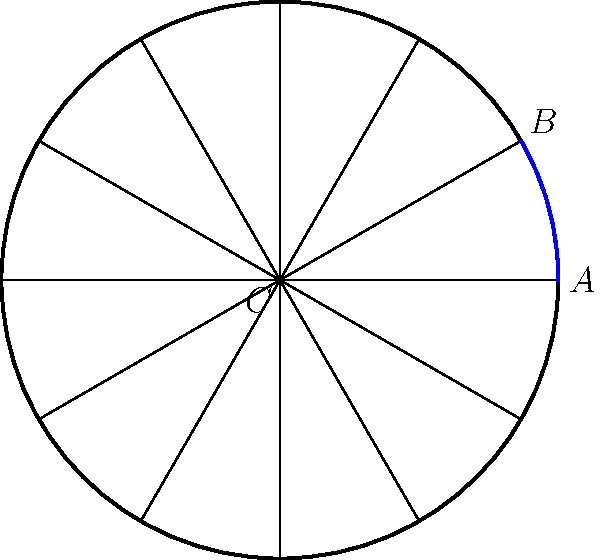A color wheel is represented as a regular dodecagon (12-sided polygon). If angle $\angle ACB$ measures $30^\circ$, what is the measure of the central angle $\angle AOB$, where $O$ is the center of the polygon? Let's approach this step-by-step:

1) In a regular dodecagon, there are 12 congruent central angles.

2) The sum of angles in a circle is $360^\circ$, so each central angle measures:
   $$\frac{360^\circ}{12} = 30^\circ$$

3) In the diagram, $\angle ACB$ is an inscribed angle, and $\angle AOB$ is the corresponding central angle.

4) There's a theorem in geometry that states: An inscribed angle is half the measure of the central angle that subtends the same arc.

5) Mathematically, this means:
   $$\angle ACB = \frac{1}{2} \angle AOB$$

6) We're given that $\angle ACB = 30^\circ$, so:
   $$30^\circ = \frac{1}{2} \angle AOB$$

7) To find $\angle AOB$, we multiply both sides by 2:
   $$\angle AOB = 2 * 30^\circ = 60^\circ$$

Therefore, the measure of the central angle $\angle AOB$ is $60^\circ$.
Answer: $60^\circ$ 